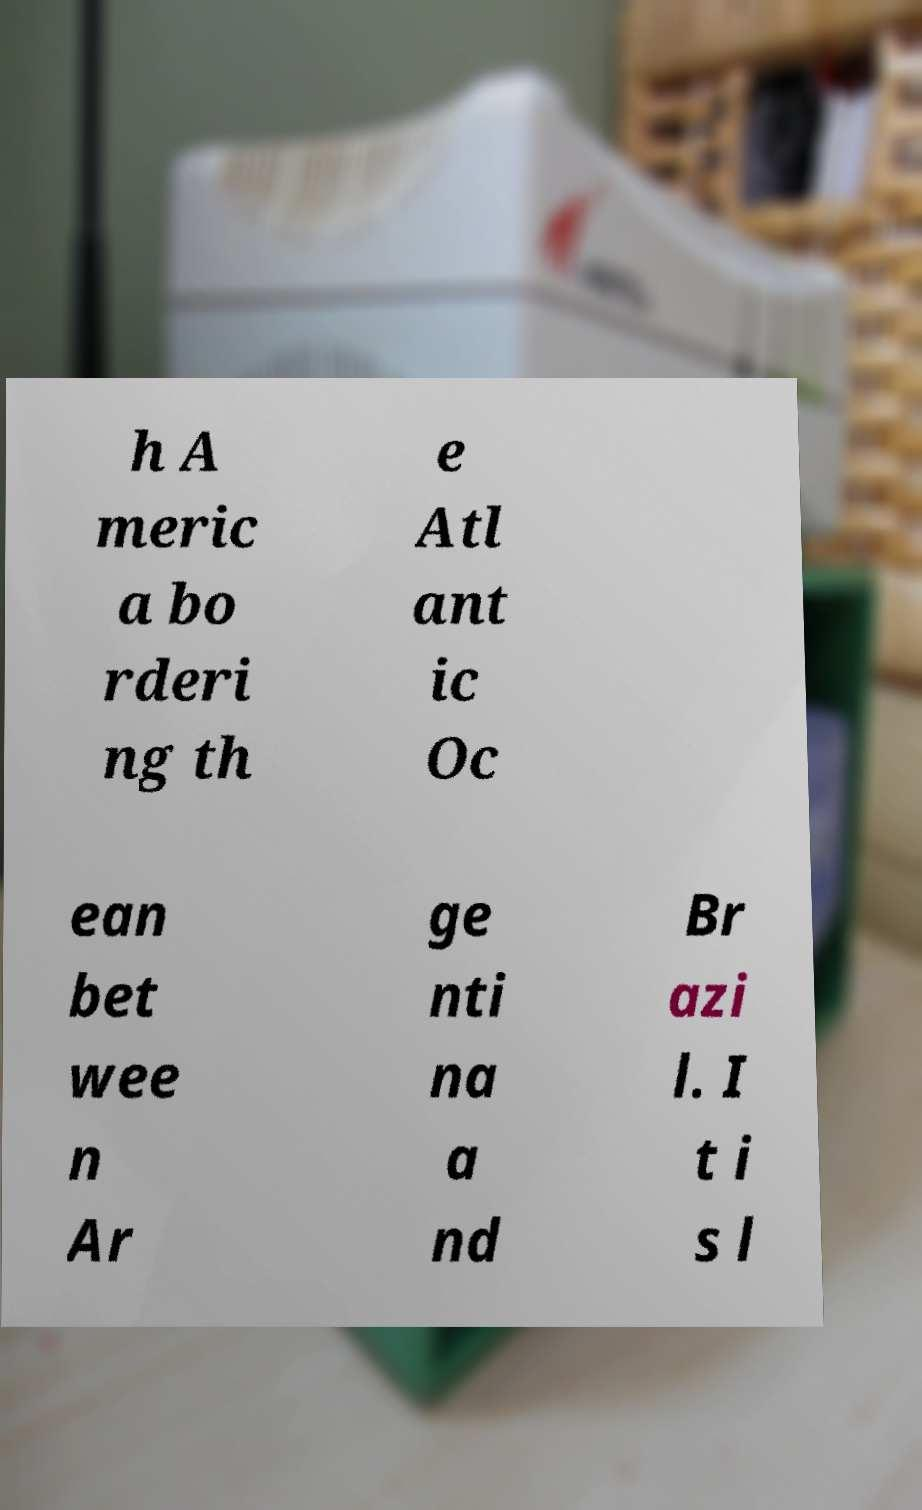I need the written content from this picture converted into text. Can you do that? h A meric a bo rderi ng th e Atl ant ic Oc ean bet wee n Ar ge nti na a nd Br azi l. I t i s l 